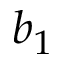Convert formula to latex. <formula><loc_0><loc_0><loc_500><loc_500>b _ { 1 }</formula> 